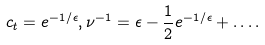Convert formula to latex. <formula><loc_0><loc_0><loc_500><loc_500>c _ { t } = e ^ { - 1 / \epsilon } , \nu ^ { - 1 } = \epsilon - \frac { 1 } { 2 } e ^ { - 1 / \epsilon } + \dots .</formula> 